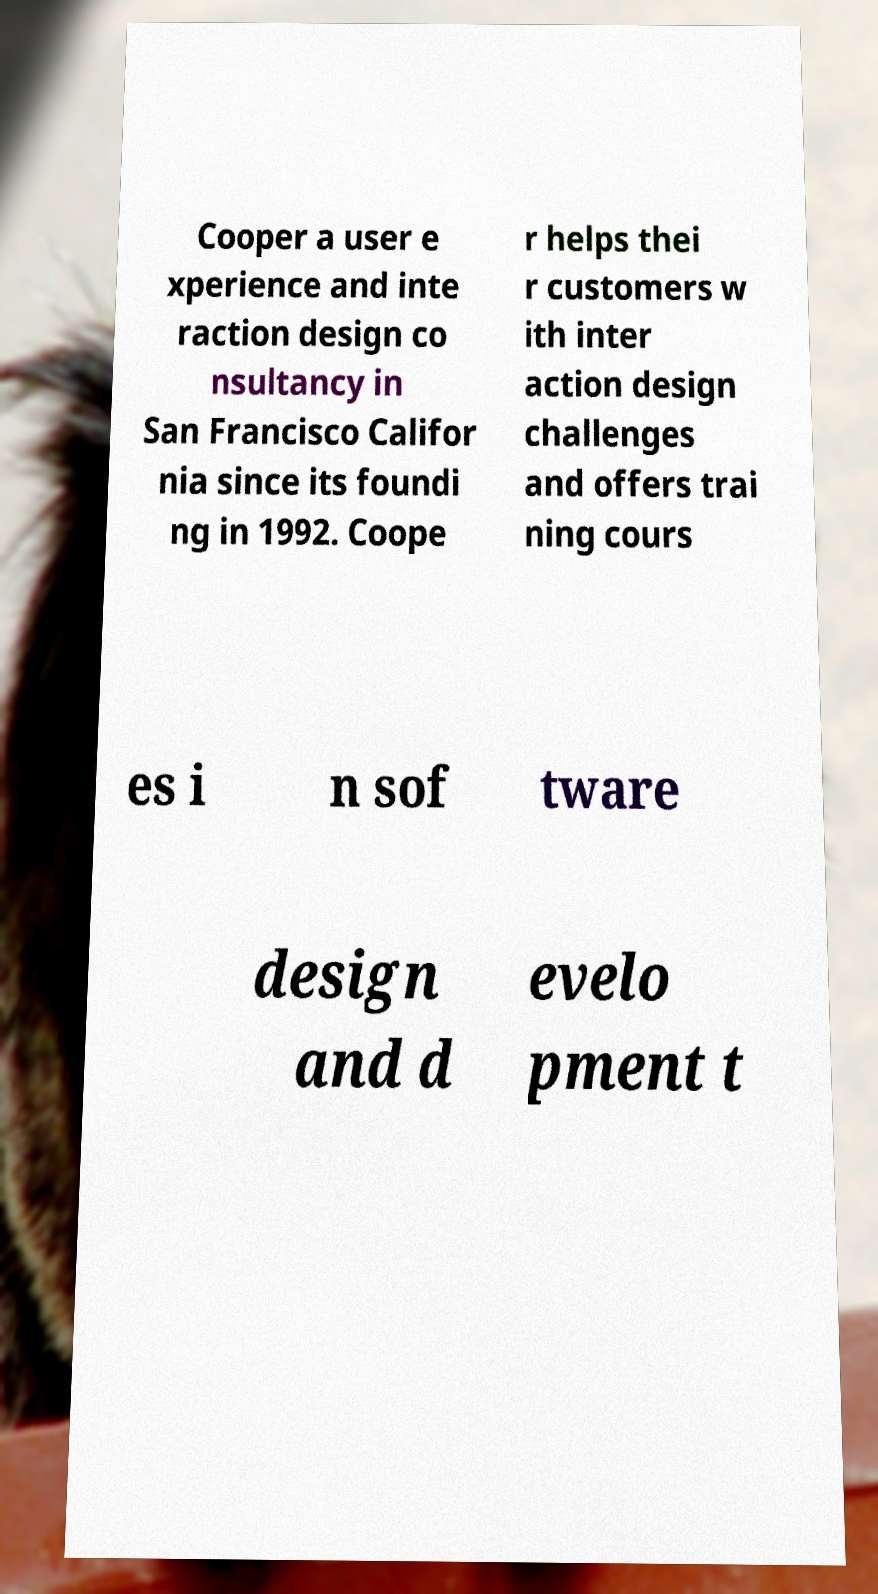Can you accurately transcribe the text from the provided image for me? Cooper a user e xperience and inte raction design co nsultancy in San Francisco Califor nia since its foundi ng in 1992. Coope r helps thei r customers w ith inter action design challenges and offers trai ning cours es i n sof tware design and d evelo pment t 